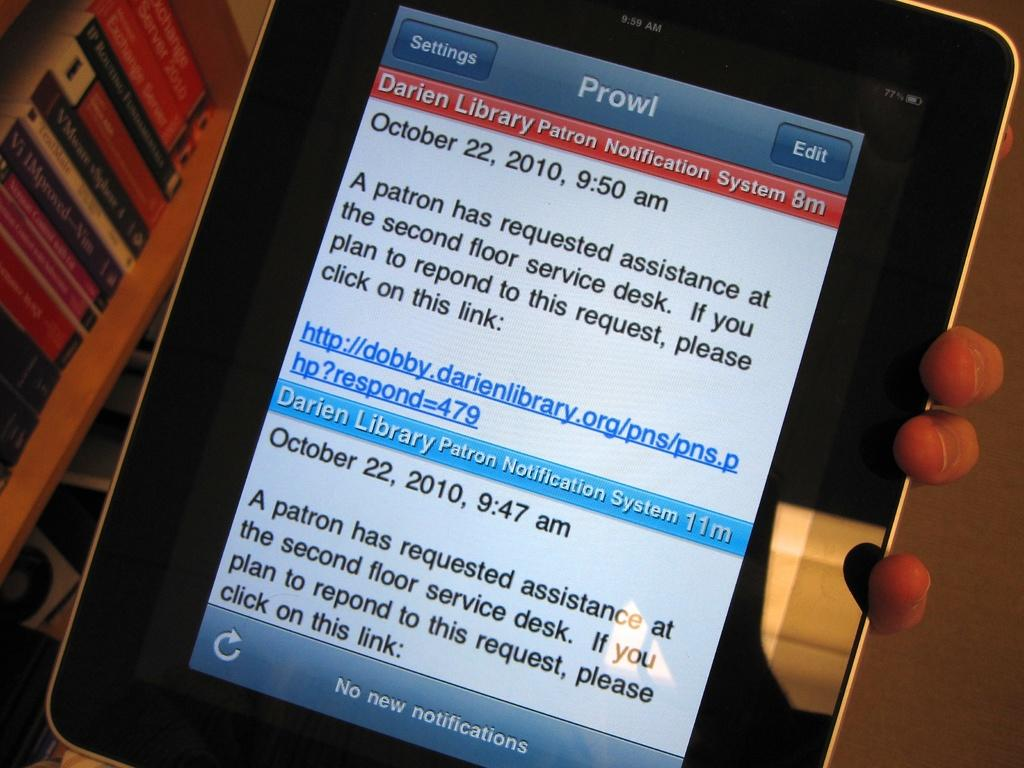<image>
Describe the image concisely. An ipad with a notification from "Prowl" alerting someone a patron needs assistance at the front desk of a Library. 